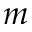<formula> <loc_0><loc_0><loc_500><loc_500>m</formula> 